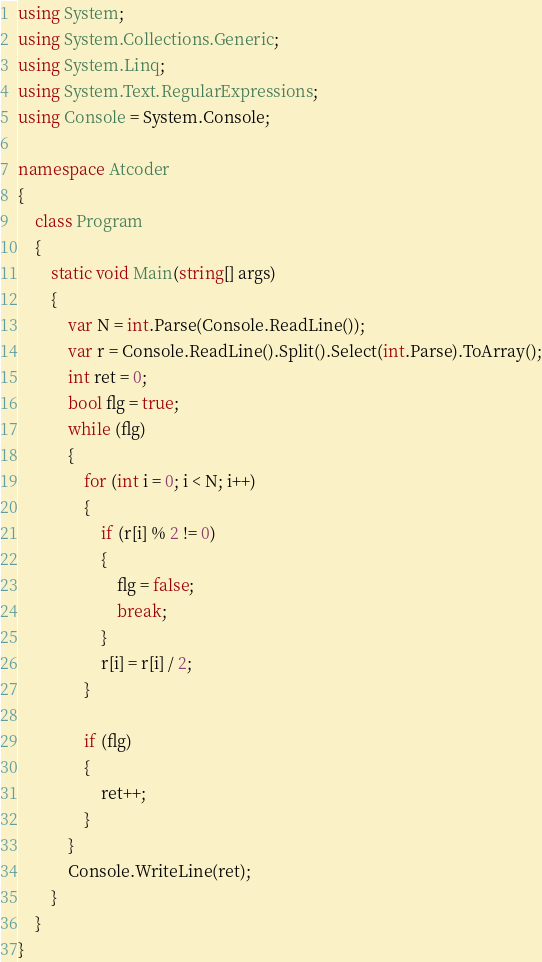Convert code to text. <code><loc_0><loc_0><loc_500><loc_500><_C#_>using System;
using System.Collections.Generic;
using System.Linq;
using System.Text.RegularExpressions;
using Console = System.Console;

namespace Atcoder
{
    class Program
    {
        static void Main(string[] args)
        {
            var N = int.Parse(Console.ReadLine());
            var r = Console.ReadLine().Split().Select(int.Parse).ToArray();
            int ret = 0;
            bool flg = true;
            while (flg)
            {
                for (int i = 0; i < N; i++)
                {
                    if (r[i] % 2 != 0)
                    {
                        flg = false;
                        break;
                    }
                    r[i] = r[i] / 2;
                }

                if (flg)
                { 
                    ret++;
                }
            }
            Console.WriteLine(ret);
        }
    }
}</code> 